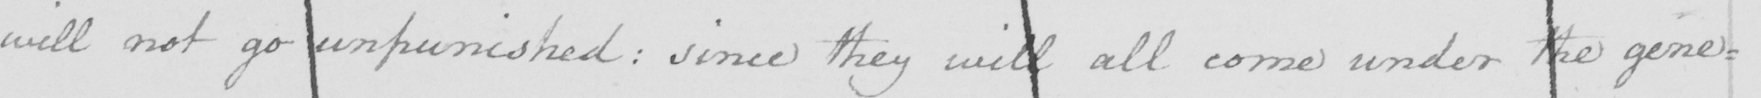Please transcribe the handwritten text in this image. will not go unpunished: since they will all come under the general 